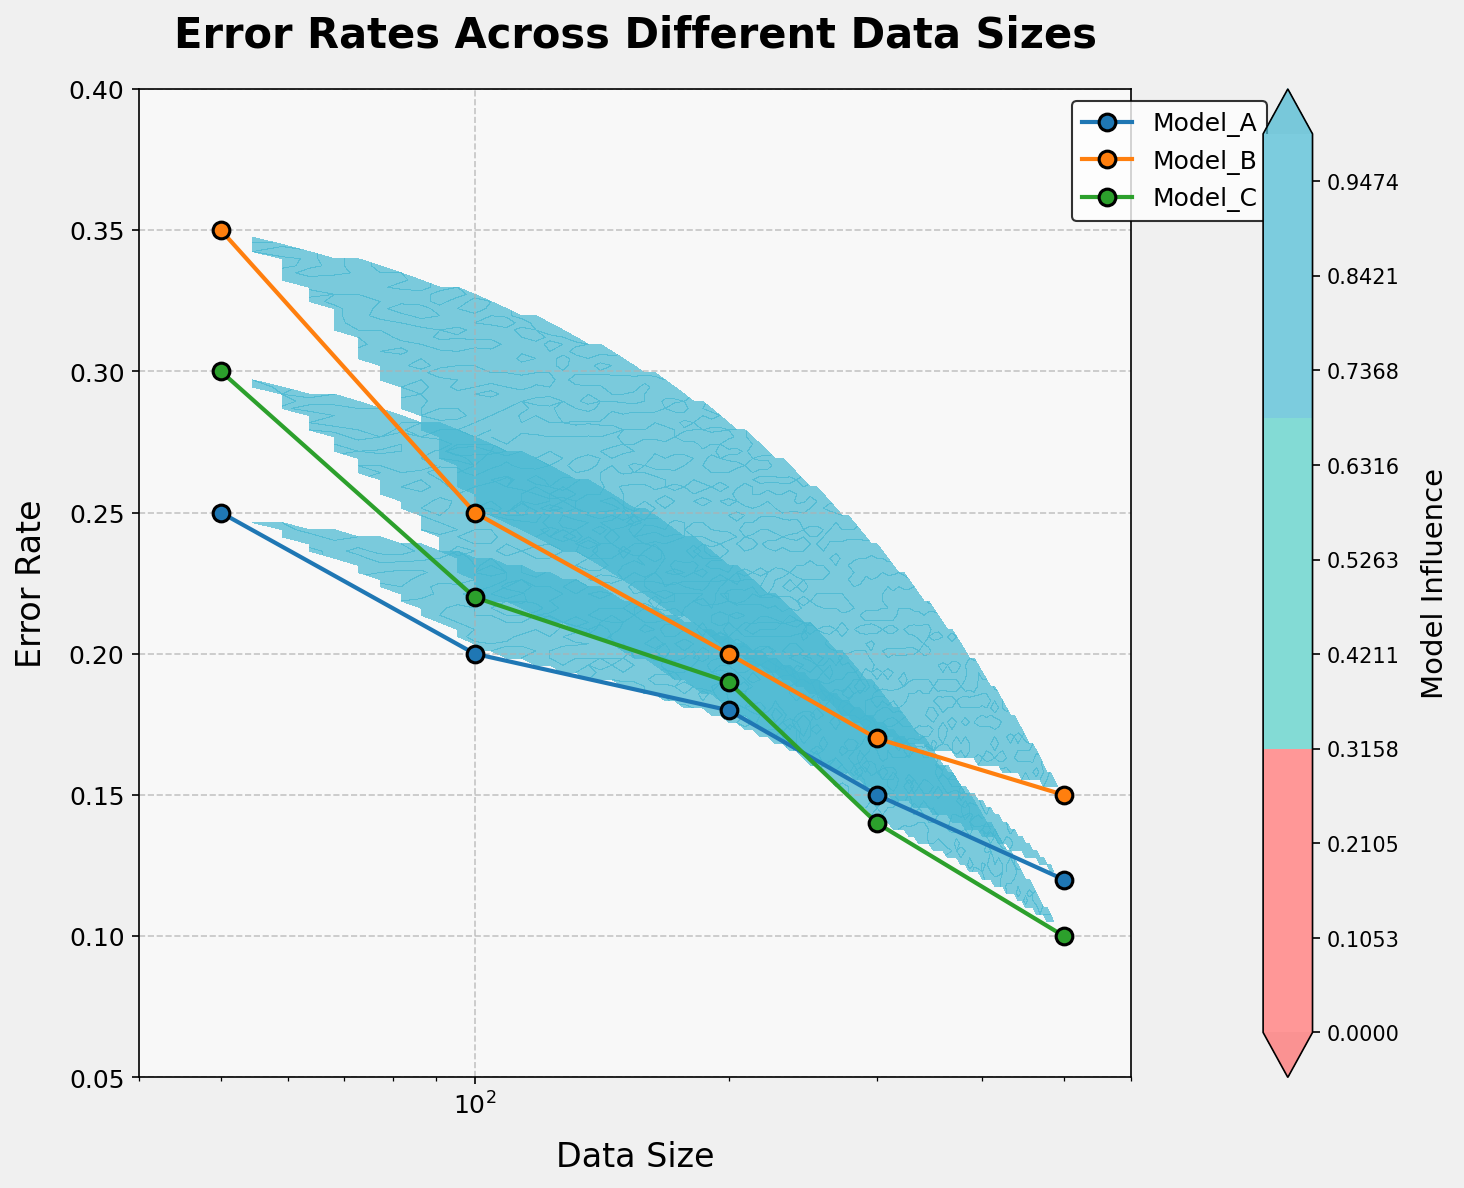What's the title of the plot? The title of the plot is typically displayed at the top in bold and a larger font. In this case, the title "Error Rates Across Different Data Sizes" is clearly visible.
Answer: Error Rates Across Different Data Sizes What are the labels on the X and Y axes? The X and Y axes labels are fundamental and located near the respective axes. Here, the X-axis is labeled "Data Size" and the Y-axis is labeled "Error Rate".
Answer: Data Size; Error Rate What is the general trend for Model_A's error rate as data size increases? By analyzing the plot, we see Model_A's error rate points decrease as the data size increases from 50 to 500, indicating a downward trend.
Answer: Decreasing Which model shows the lowest error rate for a data size of 300? Reviewing the plot's data-point pattern, Model_C shows an error rate of 0.14 at a data size of 300, which is the lowest among the three models.
Answer: Model_C What is the range of data sizes displayed in the plot? The X-axis covers the data sizes' range, starting from the minimum at 50 to the maximum at 500.
Answer: 50 to 500 Compare the error rates of Model_B and Model_C at a data size of 100. Which one is lower? The plot shows that at a data size of 100, Model_B has an error rate of 0.25, and Model_C has an error rate of 0.22. Therefore, Model_C has a lower error rate.
Answer: Model_C What are the overall color tones used in the plot and what do they signify? The plot uses a custom colormap in shades of red, turquoise, and blue. These colors signify different levels of model influence.
Answer: Red, turquoise, blue By approximately how much did the error rate of Model_B decrease when the data size increased from 50 to 100? Examining the plotted data, Model_B's error rate decreased from 0.35 to 0.25, resulting in an approximate decrease of 0.10.
Answer: 0.10 Which model shows the most drastic improvement in error rate as data size increases from 50 to 500? By comparing the plots, Model_C shows the error rate decreasing significantly from 0.30 to 0.10, making it the model with the most drastic improvement.
Answer: Model_C 